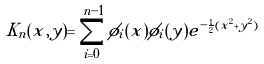Convert formula to latex. <formula><loc_0><loc_0><loc_500><loc_500>K _ { n } ( x , y ) = \sum _ { i = 0 } ^ { n - 1 } \phi _ { i } ( x ) \phi _ { i } ( y ) e ^ { - \frac { 1 } { 2 } ( x ^ { 2 } + y ^ { 2 } ) }</formula> 